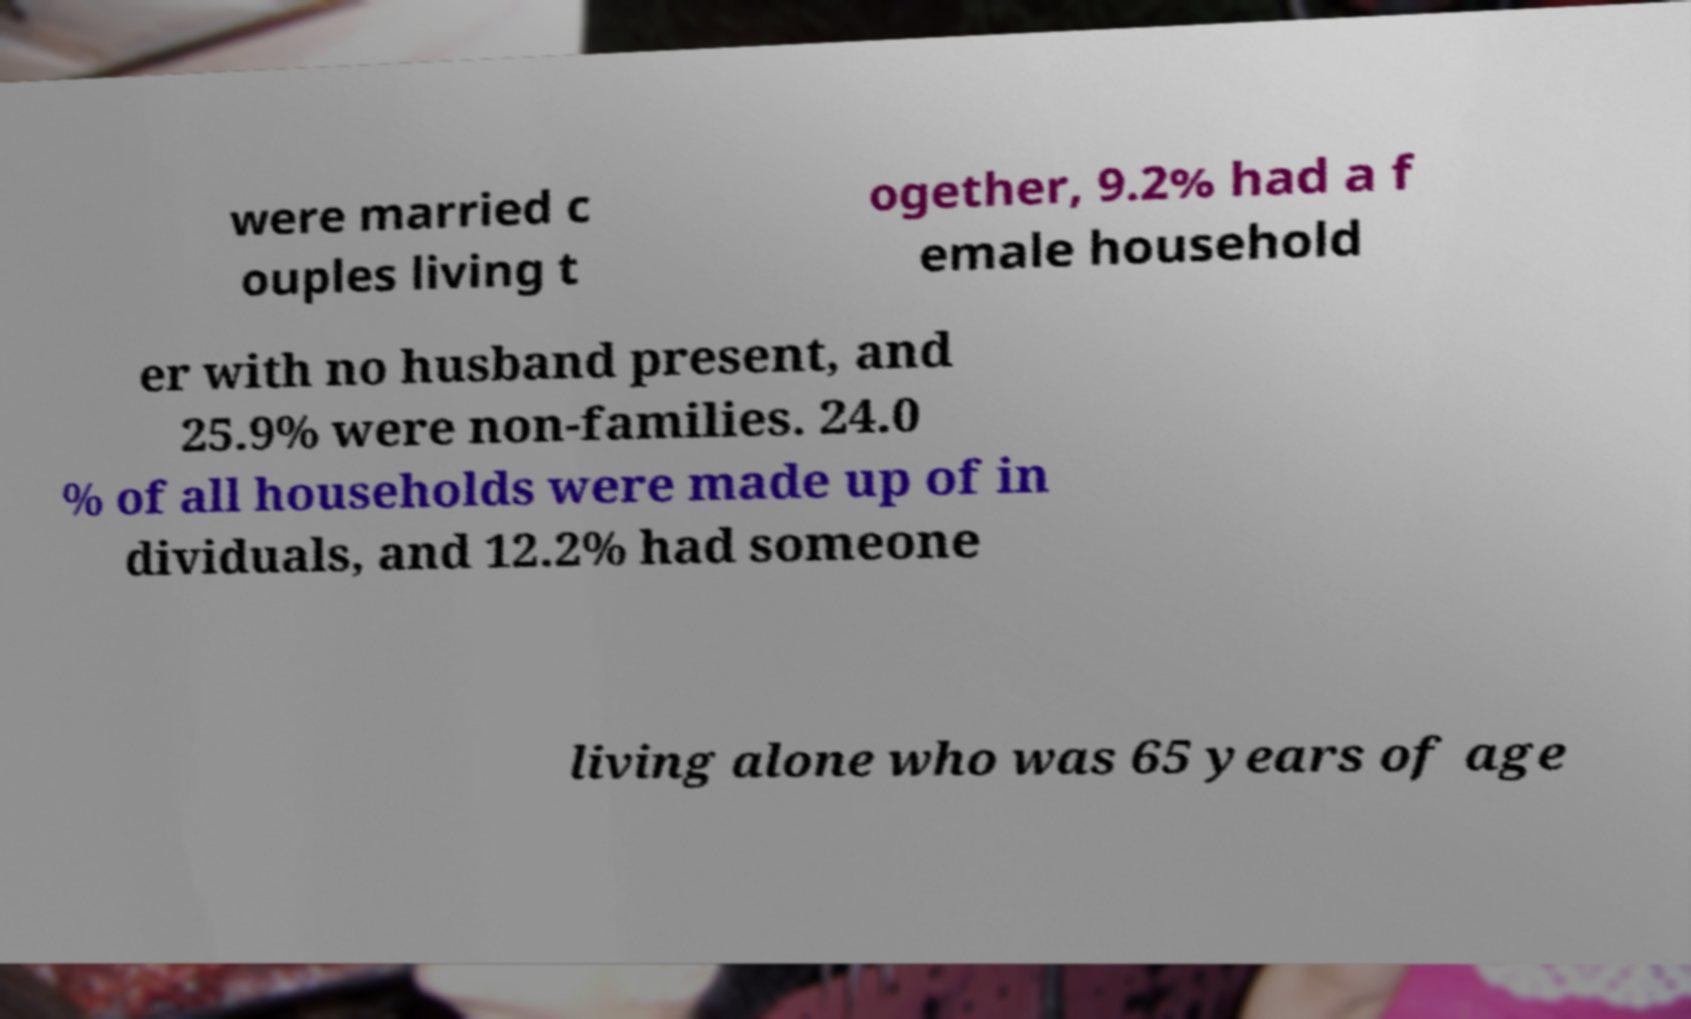Could you extract and type out the text from this image? were married c ouples living t ogether, 9.2% had a f emale household er with no husband present, and 25.9% were non-families. 24.0 % of all households were made up of in dividuals, and 12.2% had someone living alone who was 65 years of age 